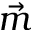Convert formula to latex. <formula><loc_0><loc_0><loc_500><loc_500>\vec { m }</formula> 